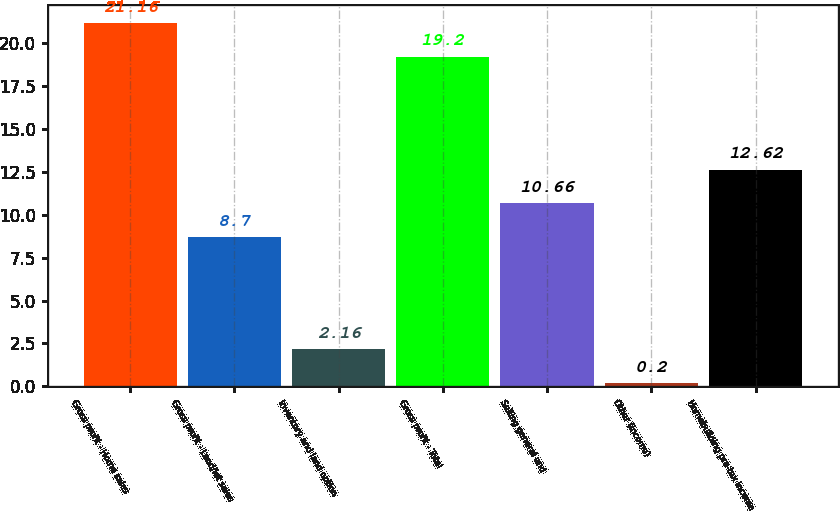Convert chart to OTSL. <chart><loc_0><loc_0><loc_500><loc_500><bar_chart><fcel>Gross profit - Home sales<fcel>Gross profit - Land/lot sales<fcel>Inventory and land option<fcel>Gross profit - Total<fcel>Selling general and<fcel>Other (income)<fcel>Homebuilding pre-tax income<nl><fcel>21.16<fcel>8.7<fcel>2.16<fcel>19.2<fcel>10.66<fcel>0.2<fcel>12.62<nl></chart> 